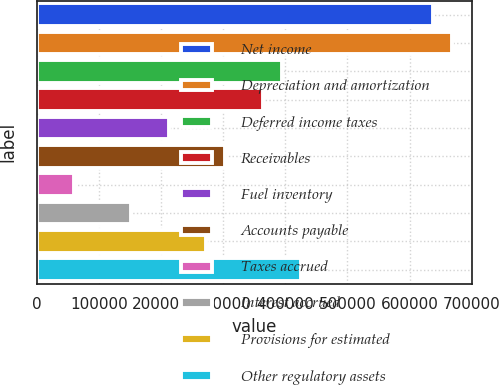Convert chart to OTSL. <chart><loc_0><loc_0><loc_500><loc_500><bar_chart><fcel>Net income<fcel>Depreciation and amortization<fcel>Deferred income taxes<fcel>Receivables<fcel>Fuel inventory<fcel>Accounts payable<fcel>Taxes accrued<fcel>Interest accrued<fcel>Provisions for estimated<fcel>Other regulatory assets<nl><fcel>637238<fcel>667581<fcel>394493<fcel>364149<fcel>212433<fcel>303463<fcel>60717.4<fcel>151747<fcel>273120<fcel>424836<nl></chart> 